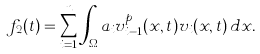<formula> <loc_0><loc_0><loc_500><loc_500>f _ { 2 } ( t ) = \sum _ { i = 1 } ^ { n } \int _ { \Omega } a _ { i } v _ { i - 1 } ^ { p } ( x , t ) v _ { i } ( x , t ) \, d x .</formula> 